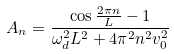<formula> <loc_0><loc_0><loc_500><loc_500>A _ { n } = \frac { \cos \frac { 2 \pi n } { L } - 1 } { \omega _ { d } ^ { 2 } L ^ { 2 } + 4 \pi ^ { 2 } n ^ { 2 } v _ { 0 } ^ { 2 } }</formula> 